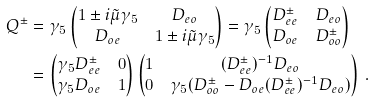<formula> <loc_0><loc_0><loc_500><loc_500>Q ^ { \pm } & = \gamma _ { 5 } \begin{pmatrix} 1 \pm i \tilde { \mu } \gamma _ { 5 } & D _ { e o } \\ D _ { o e } & 1 \pm i \tilde { \mu } \gamma _ { 5 } \\ \end{pmatrix} = \gamma _ { 5 } \begin{pmatrix} D _ { e e } ^ { \pm } & D _ { e o } \\ D _ { o e } & D _ { o o } ^ { \pm } \\ \end{pmatrix} \\ & = \begin{pmatrix} \gamma _ { 5 } D _ { e e } ^ { \pm } & 0 \\ \gamma _ { 5 } D _ { o e } & 1 \\ \end{pmatrix} \begin{pmatrix} 1 & ( D _ { e e } ^ { \pm } ) ^ { - 1 } D _ { e o } \\ 0 & \gamma _ { 5 } ( D _ { o o } ^ { \pm } - D _ { o e } ( D _ { e e } ^ { \pm } ) ^ { - 1 } D _ { e o } ) \\ \end{pmatrix} \, .</formula> 